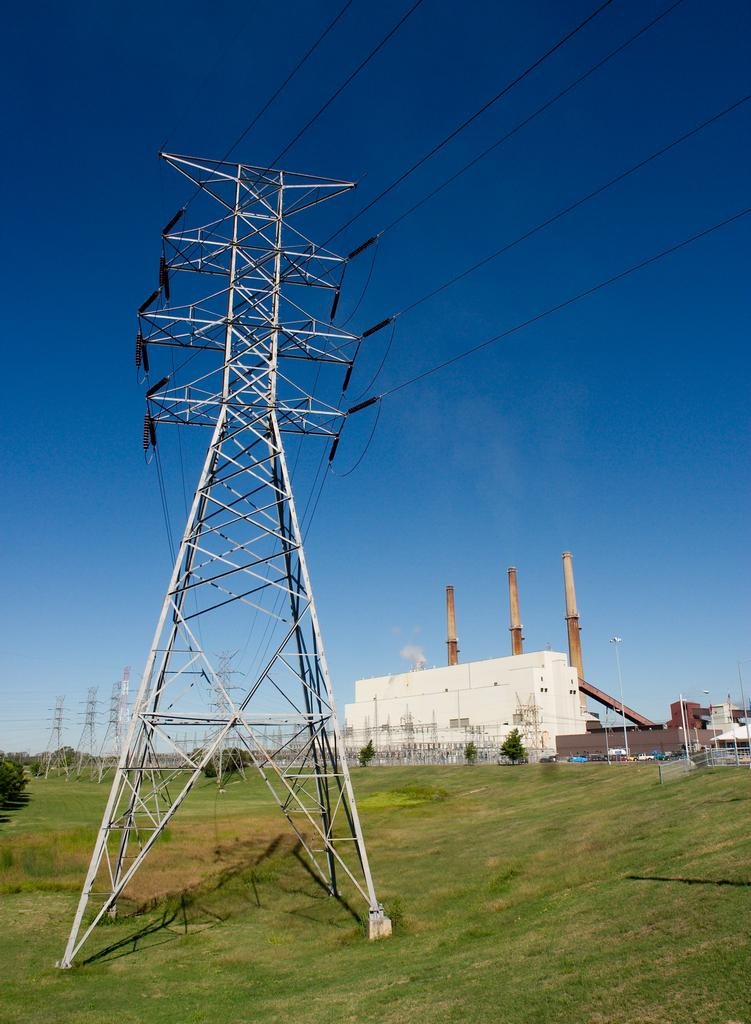What structures can be seen in the image? There are electric poles, buildings, and chimneys in the image. What is connected to the electric poles? Electric cables are connected to the electric poles in the image. What type of vegetation is present in the image? There are trees in the image. What can be seen in the background of the image? The sky is visible in the background of the image, and there are clouds in the sky. What type of locket is hanging from the electric pole in the image? There is no locket hanging from the electric pole in the image. What type of lunch is being prepared in the chimneys in the image? There is no indication of food preparation or lunch in the image; the chimneys are simply part of the buildings. 